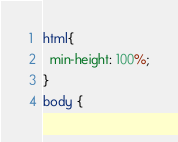Convert code to text. <code><loc_0><loc_0><loc_500><loc_500><_CSS_>html{
  min-height: 100%;
}
body {</code> 